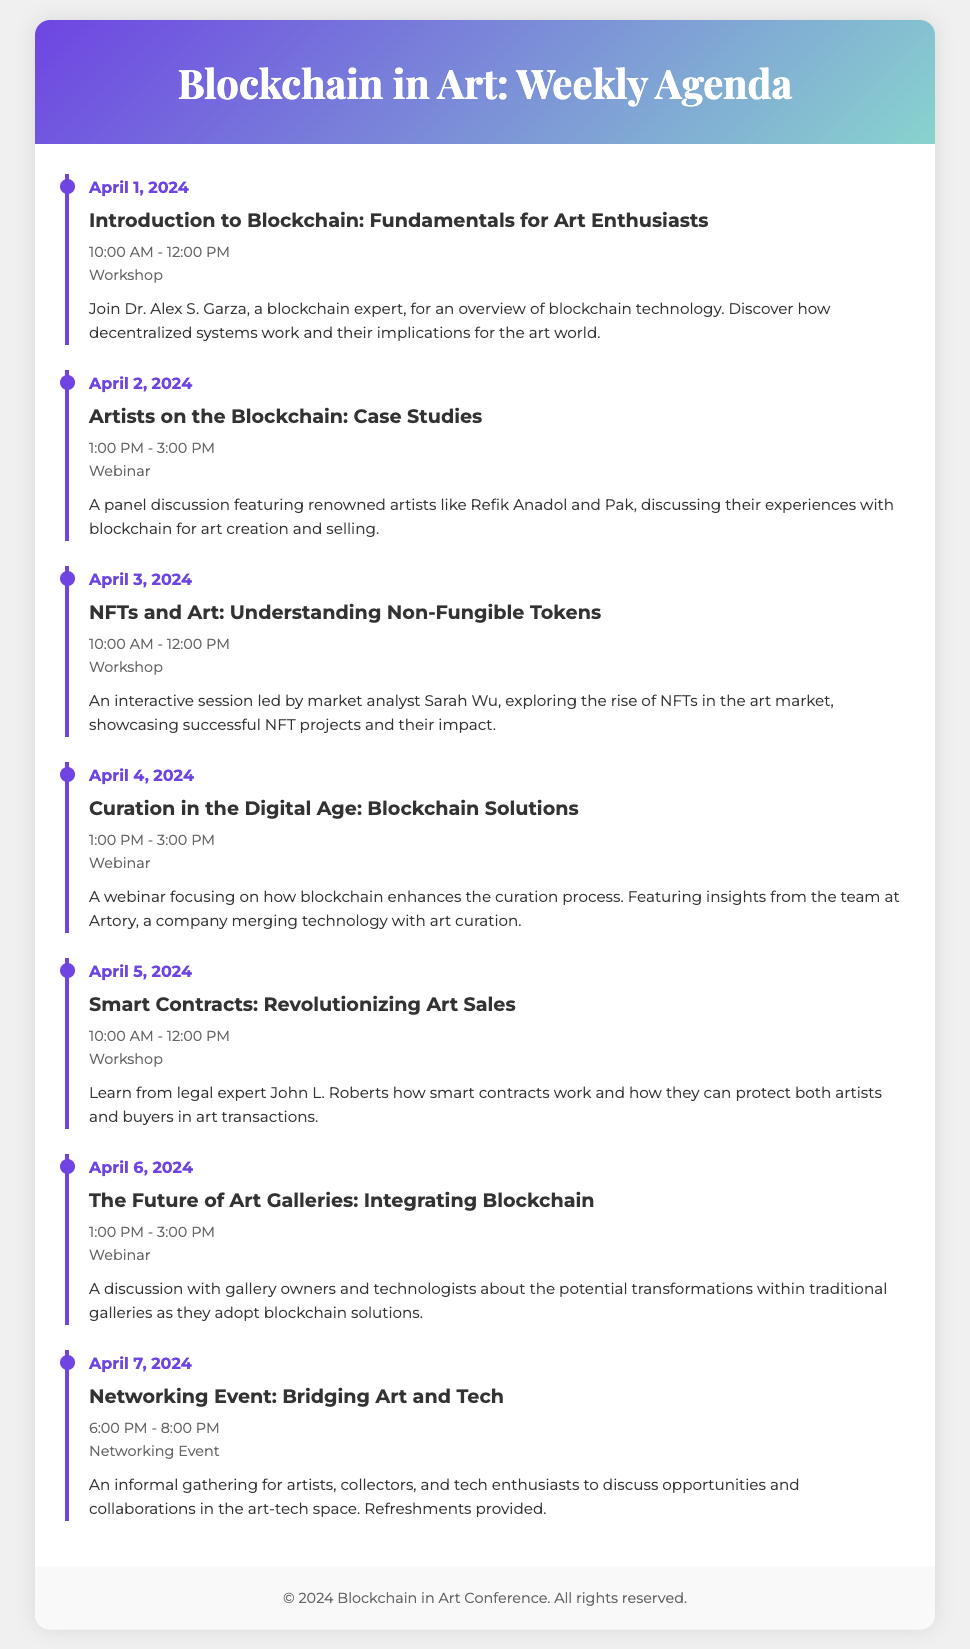What is the date of the first workshop? The first workshop focuses on the fundamentals of blockchain for art enthusiasts, scheduled for April 1, 2024.
Answer: April 1, 2024 Who is leading the session on NFTs? Sarah Wu, a market analyst, leads the workshop discussing NFTs in the art market.
Answer: Sarah Wu What time does the webinar on Curation in the Digital Age start? This webinar is scheduled to begin at 1:00 PM on April 4, 2024.
Answer: 1:00 PM What type of event is held on April 7, 2024? The final event of the week is an informal gathering for networking in the art-tech space.
Answer: Networking Event How many webinars are scheduled during the week? There are three webinars included in the agenda for this week-long event.
Answer: Three Who are some of the featured artists discussing blockchain experiences? Renowned artists like Refik Anadol and Pak are part of the panel discussion on April 2, 2024.
Answer: Refik Anadol, Pak What is the main focus of the workshop on Smart Contracts? This workshop covers how smart contracts work to protect artists and buyers in art transactions.
Answer: Protect both artists and buyers What color is used for the event date in the agenda? The event date is highlighted in a bold blue color corresponding to the theme of the document.
Answer: Blue 